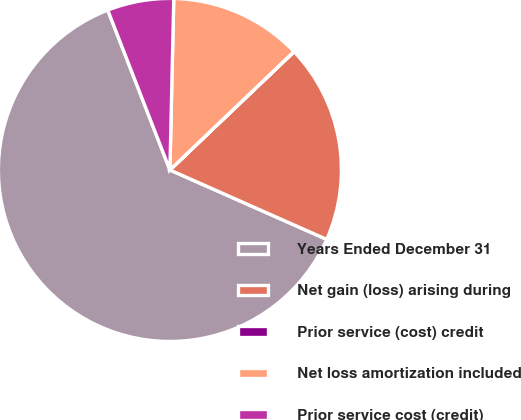Convert chart. <chart><loc_0><loc_0><loc_500><loc_500><pie_chart><fcel>Years Ended December 31<fcel>Net gain (loss) arising during<fcel>Prior service (cost) credit<fcel>Net loss amortization included<fcel>Prior service cost (credit)<nl><fcel>62.47%<fcel>18.75%<fcel>0.02%<fcel>12.51%<fcel>6.26%<nl></chart> 